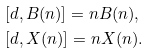Convert formula to latex. <formula><loc_0><loc_0><loc_500><loc_500>& [ d , B ( n ) ] = n B ( n ) , \\ & [ d , X ( n ) ] = n X ( n ) .</formula> 